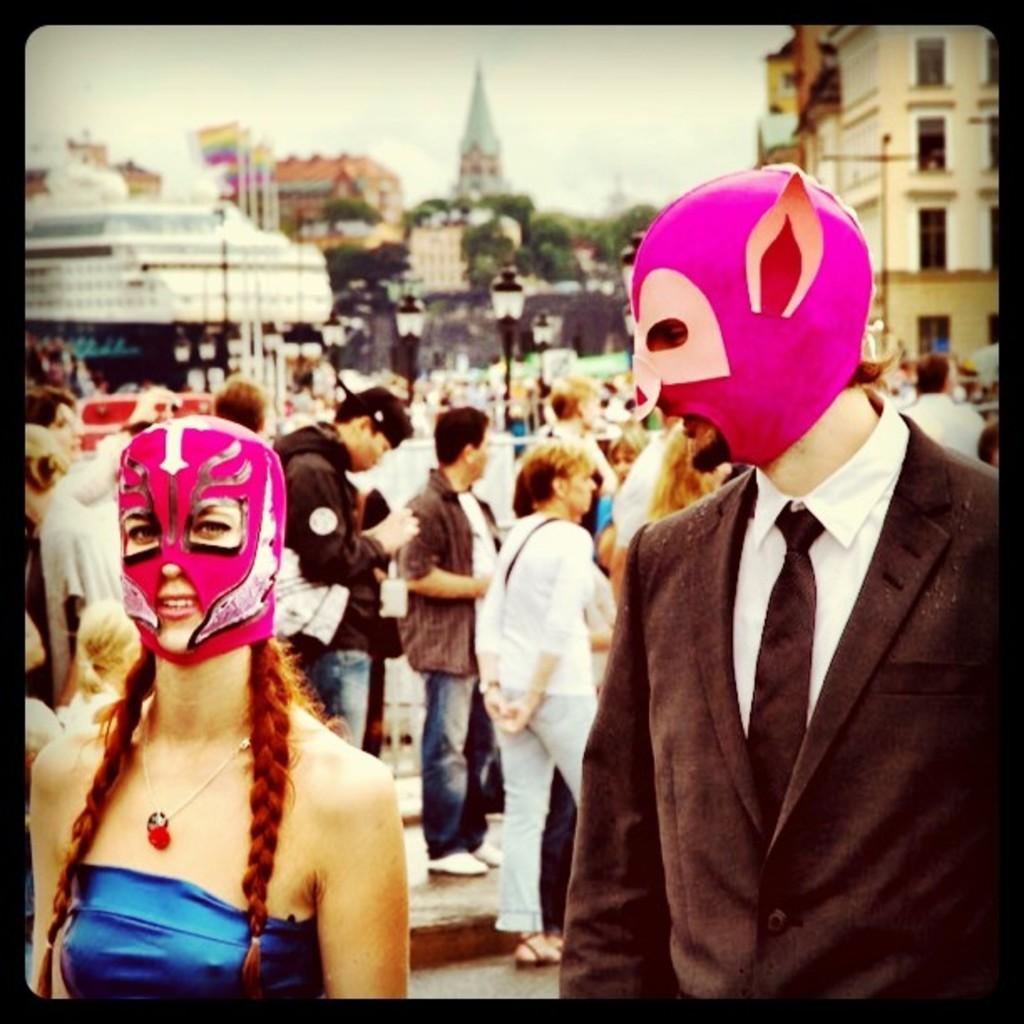What are the people in the image doing? The people in the image are standing on the road. Can you describe the appearance of some of the people? Two of the people are wearing masks. What can be seen in the background of the image? There are light poles, buildings, trees, and the sky visible in the background. What type of operation is being performed on the coast in the image? There is no operation or coast present in the image; it features people standing on a road with a background of light poles, buildings, trees, and the sky. 